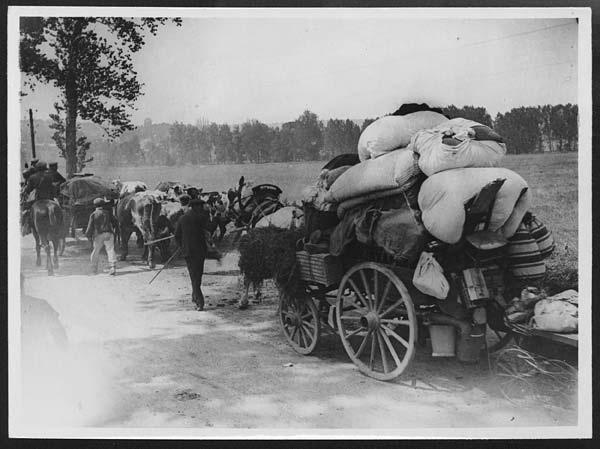What type of vehicle is displayed prominently in this photograph?
Concise answer only. Wagon. Does this picture seem old?
Concise answer only. Yes. Is the wagon overloaded?
Short answer required. Yes. What era is this?
Give a very brief answer. 1900s. Is this a current photo?
Short answer required. No. 